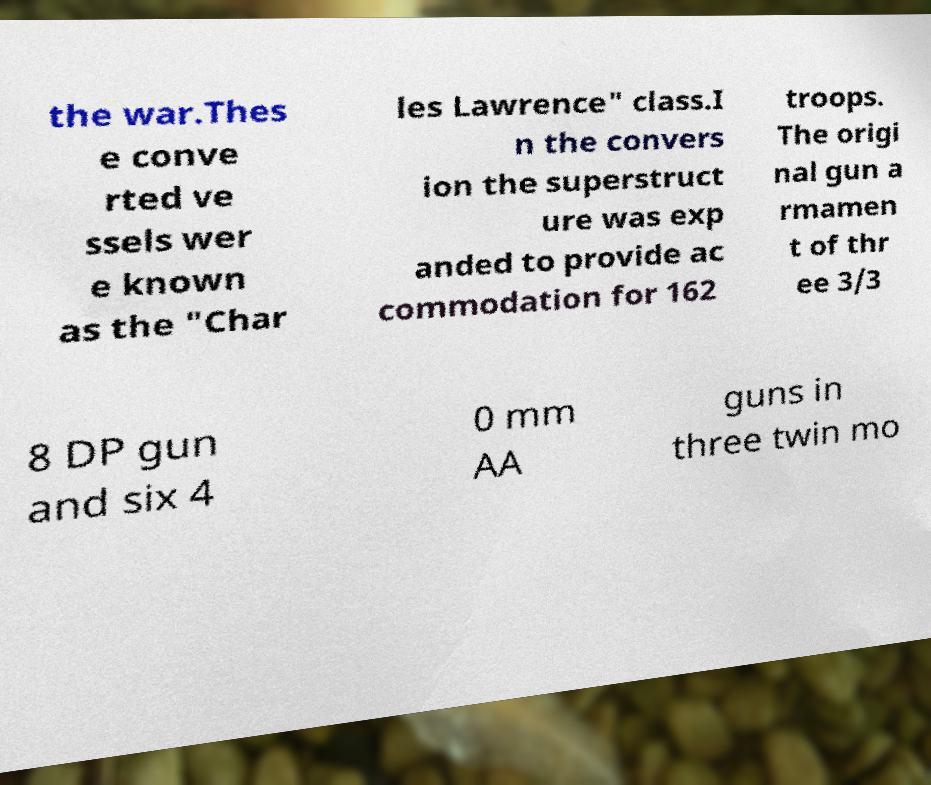Could you extract and type out the text from this image? the war.Thes e conve rted ve ssels wer e known as the "Char les Lawrence" class.I n the convers ion the superstruct ure was exp anded to provide ac commodation for 162 troops. The origi nal gun a rmamen t of thr ee 3/3 8 DP gun and six 4 0 mm AA guns in three twin mo 